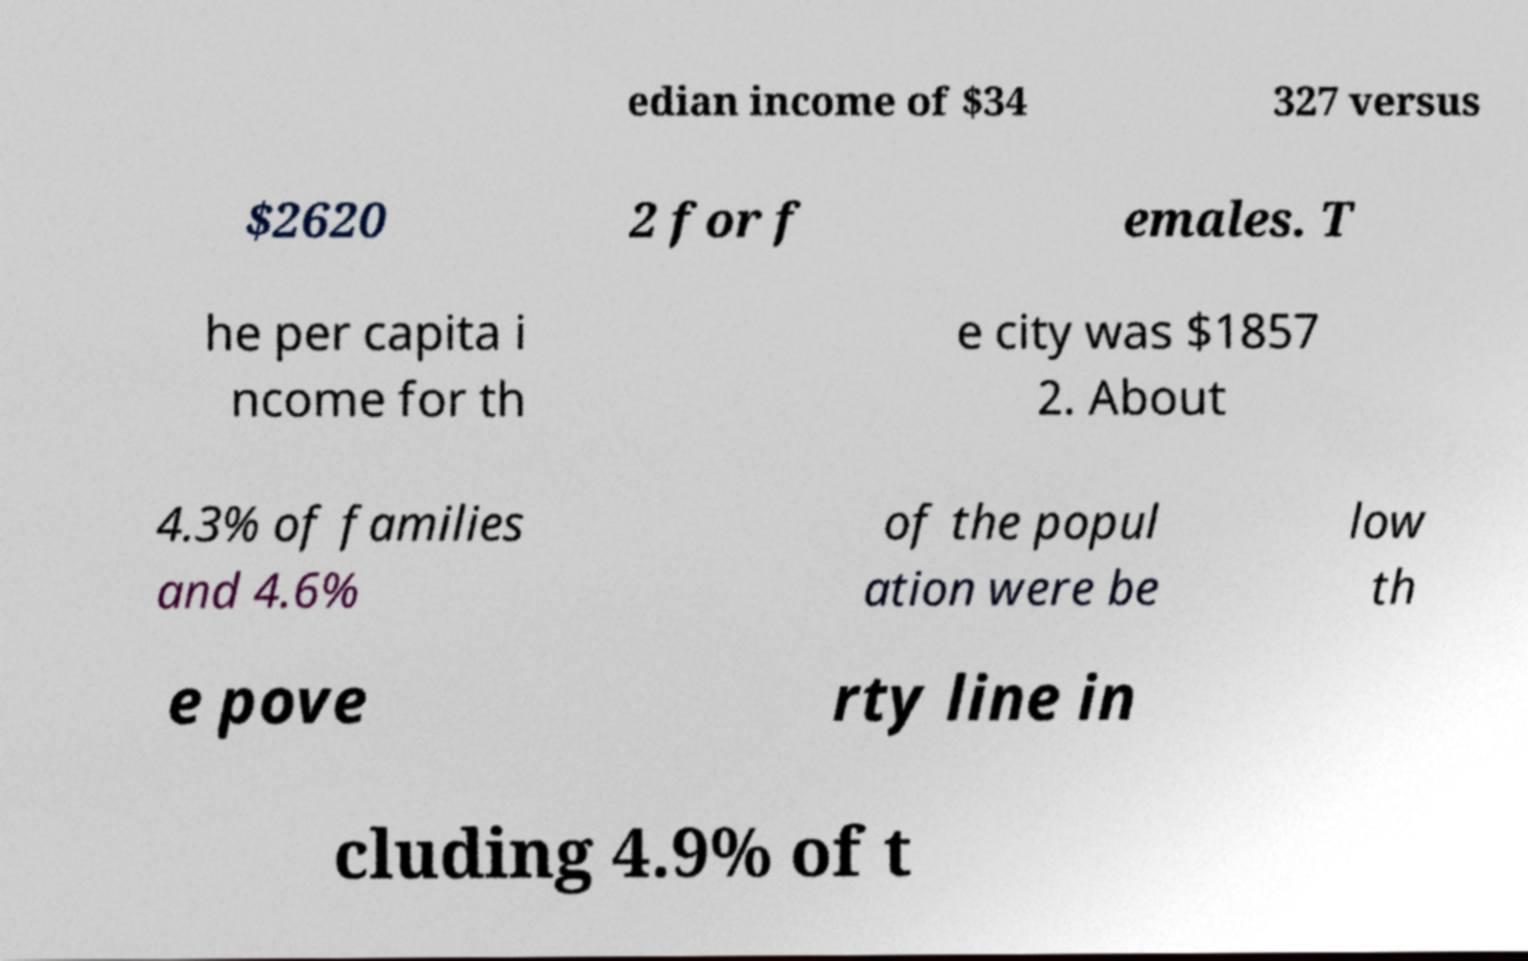I need the written content from this picture converted into text. Can you do that? edian income of $34 327 versus $2620 2 for f emales. T he per capita i ncome for th e city was $1857 2. About 4.3% of families and 4.6% of the popul ation were be low th e pove rty line in cluding 4.9% of t 